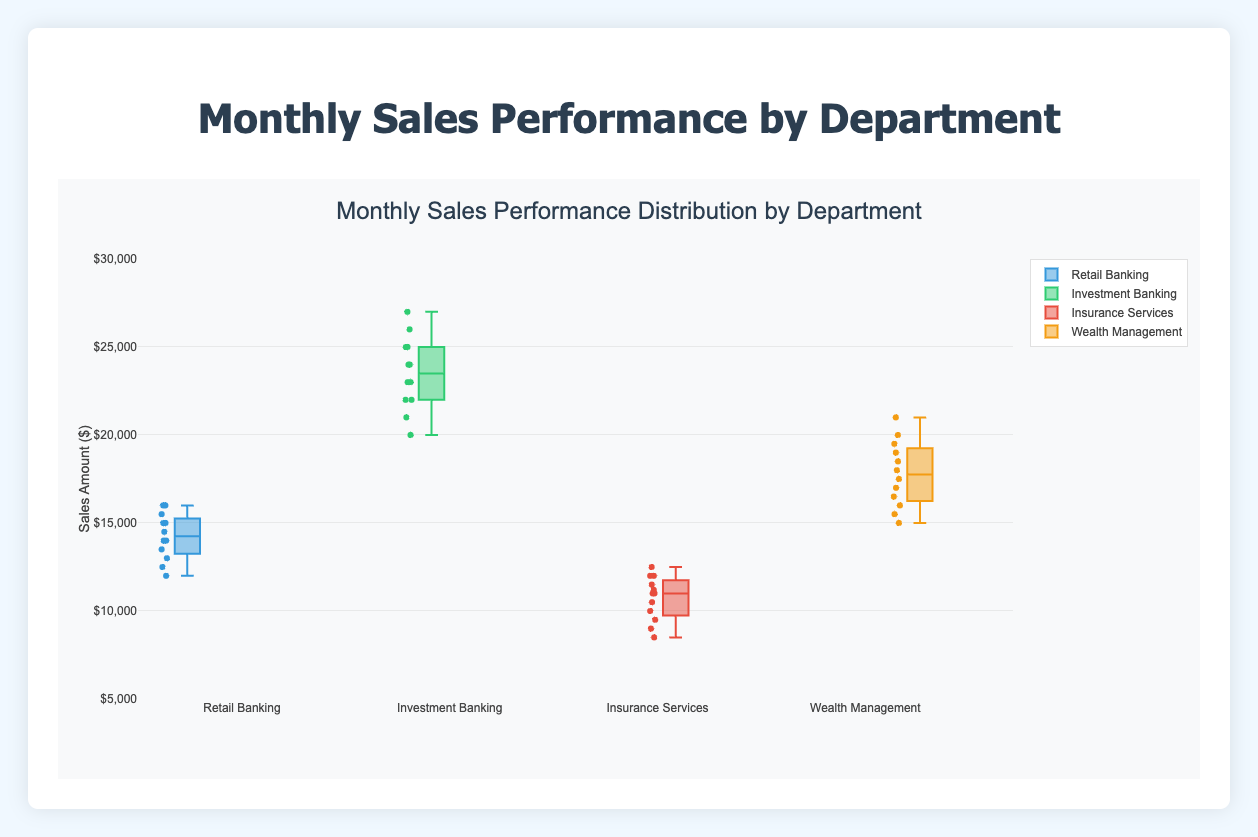What is the y-axis representing? The y-axis is labeled 'Sales Amount ($)' which indicates that it represents the amount of sales in dollars.
Answer: Sales Amount ($) Which department has the highest median sales? By examining the box plots, the Investment Banking department has the highest median sales, as its median line within the box is higher compared to the other departments.
Answer: Investment Banking Between which two months did Bob Smith see the largest increase in sales in the Investment Banking department? By analyzing the monthly sales data for Bob Smith, the largest increase in sales occurred between November and December, where sales increased from 26000 to 27000.
Answer: November to December Which department has the smallest interquartile range (IQR)? The IQR can be determined by the height of the box in each plot. The Retail Banking department has the smallest box, indicating it has the smallest interquartile range.
Answer: Retail Banking Who has the highest sales peak in any given month? Comparing the maximum values across departments, Bob Smith from the Investment Banking department has the highest peak with a sales value of 27000 in December.
Answer: Bob Smith Which department has the widest range of monthly sales? The range of sales is the difference between the maximum and minimum values in each box plot. The Investment Banking department shows the widest range, from 20000 to 27000.
Answer: Investment Banking What is the median sales value for Cara Lee in Insurance Services? The median value is shown by the line inside the box of the Insurance Services plot. It is approximately 11000.
Answer: 11000 How does David Patel's performance compare to Cara Lee's in terms of maximum sales? David Patel's maximum sales in the Wealth Management department is 21000, which is higher than Cara Lee's maximum sales of 12500 in Insurance Services.
Answer: Higher What is the range of sales values for Alice Johnson in Retail Banking? The range is calculated as the difference between the maximum and minimum values for Alice. Her sales range from 12000 to 16000, giving a range of 4000.
Answer: 4000 Which department's representative had the most consistent sales performance (least variation)? Consistency can be inferred from the lengths of the boxes and whiskers. The Retail Banking department, represented by Alice Johnson, shows the least variation, indicating the most consistent sales performance.
Answer: Retail Banking 